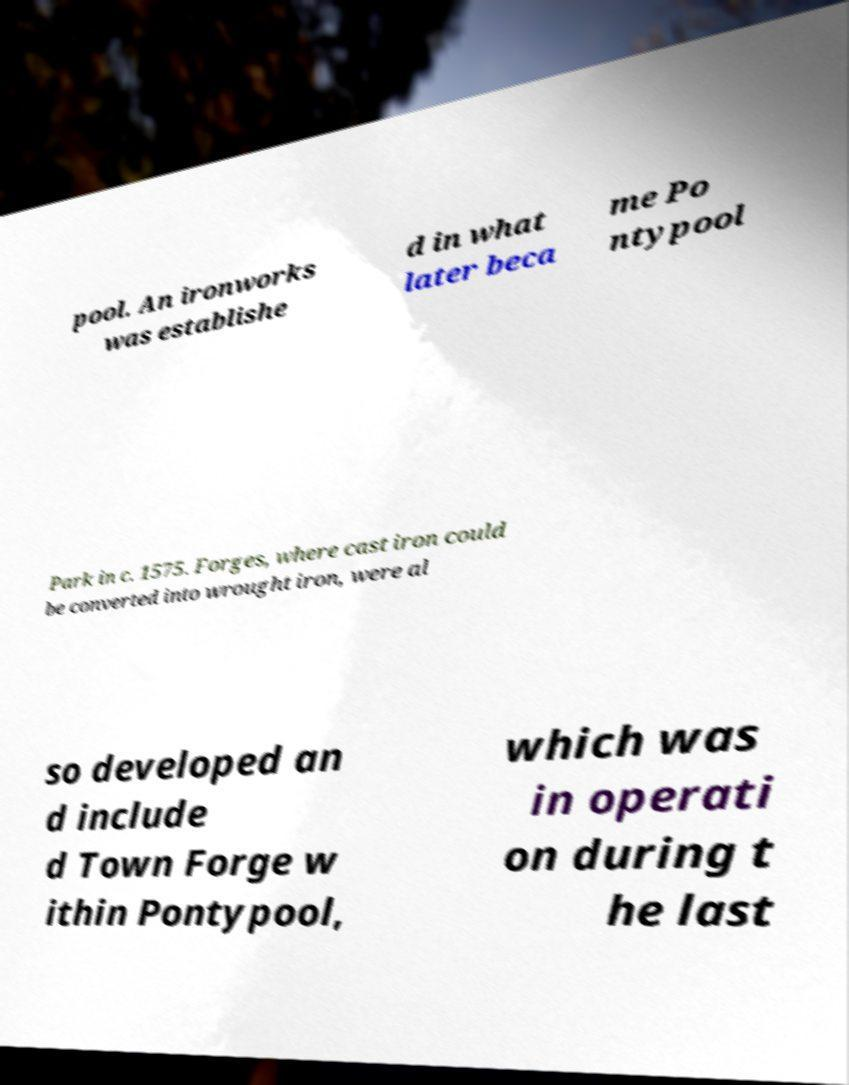There's text embedded in this image that I need extracted. Can you transcribe it verbatim? pool. An ironworks was establishe d in what later beca me Po ntypool Park in c. 1575. Forges, where cast iron could be converted into wrought iron, were al so developed an d include d Town Forge w ithin Pontypool, which was in operati on during t he last 